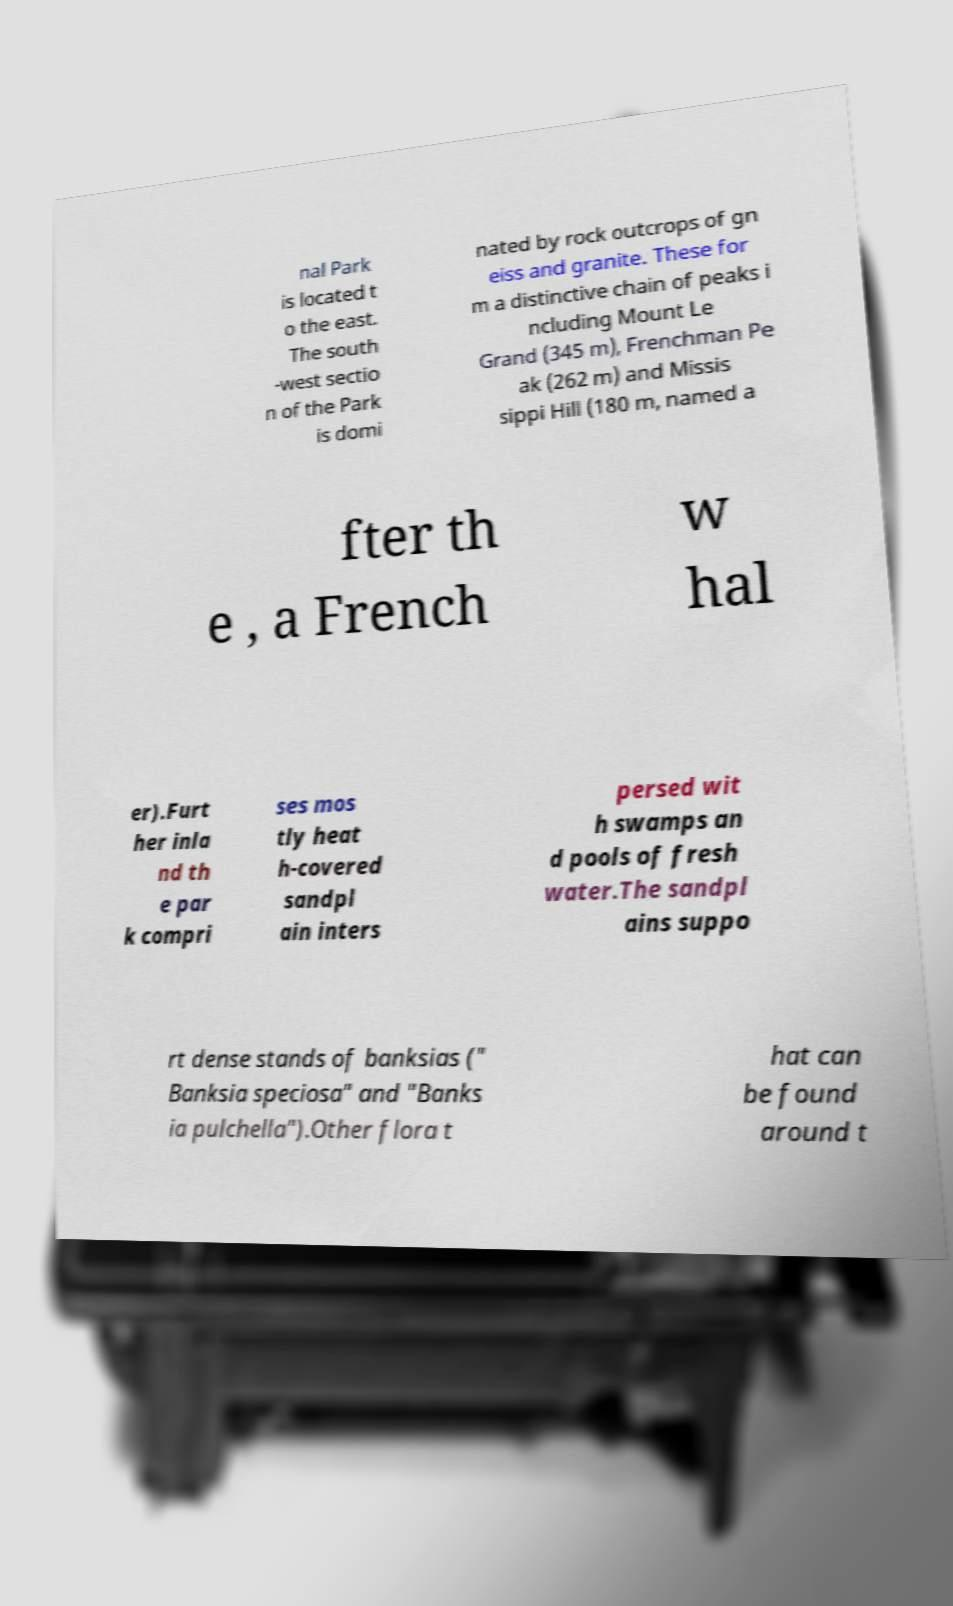For documentation purposes, I need the text within this image transcribed. Could you provide that? nal Park is located t o the east. The south -west sectio n of the Park is domi nated by rock outcrops of gn eiss and granite. These for m a distinctive chain of peaks i ncluding Mount Le Grand (345 m), Frenchman Pe ak (262 m) and Missis sippi Hill (180 m, named a fter th e , a French w hal er).Furt her inla nd th e par k compri ses mos tly heat h-covered sandpl ain inters persed wit h swamps an d pools of fresh water.The sandpl ains suppo rt dense stands of banksias (" Banksia speciosa" and "Banks ia pulchella").Other flora t hat can be found around t 